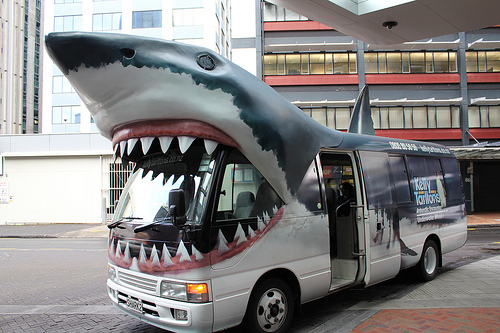<image>
Is there a shark in the bus? No. The shark is not contained within the bus. These objects have a different spatial relationship. 